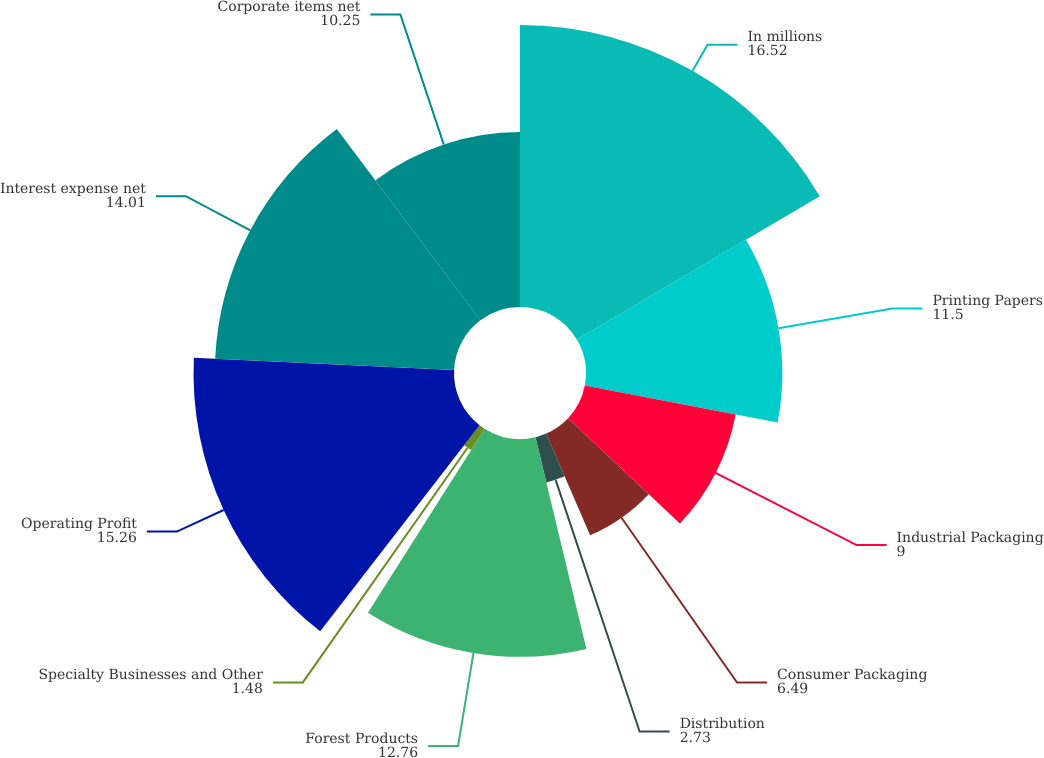Convert chart. <chart><loc_0><loc_0><loc_500><loc_500><pie_chart><fcel>In millions<fcel>Printing Papers<fcel>Industrial Packaging<fcel>Consumer Packaging<fcel>Distribution<fcel>Forest Products<fcel>Specialty Businesses and Other<fcel>Operating Profit<fcel>Interest expense net<fcel>Corporate items net<nl><fcel>16.52%<fcel>11.5%<fcel>9.0%<fcel>6.49%<fcel>2.73%<fcel>12.76%<fcel>1.48%<fcel>15.26%<fcel>14.01%<fcel>10.25%<nl></chart> 